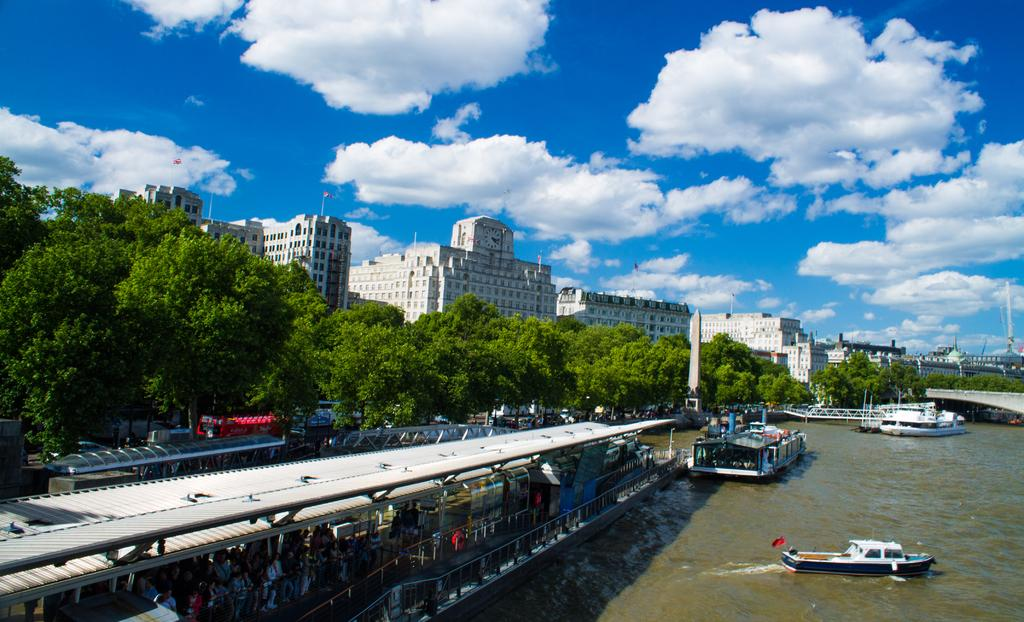What is the main subject of the image? The main subject of the image is ships on water. Are there any people visible in the image? Yes, there are persons standing in the left corner of the image. What can be seen in the background of the image? There are buildings and trees in the background of the image. Can you tell me how many owls are sitting on the ships in the image? There are no owls present in the image; it features ships on water with people standing nearby. What type of ball can be seen being used by the persons in the image? There is no ball visible in the image; the persons are standing near the ships. 